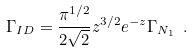Convert formula to latex. <formula><loc_0><loc_0><loc_500><loc_500>\Gamma _ { I D } = \frac { \pi ^ { 1 / 2 } } { 2 \sqrt { 2 } } z ^ { 3 / 2 } e ^ { - z } \Gamma _ { N _ { 1 } } \ .</formula> 